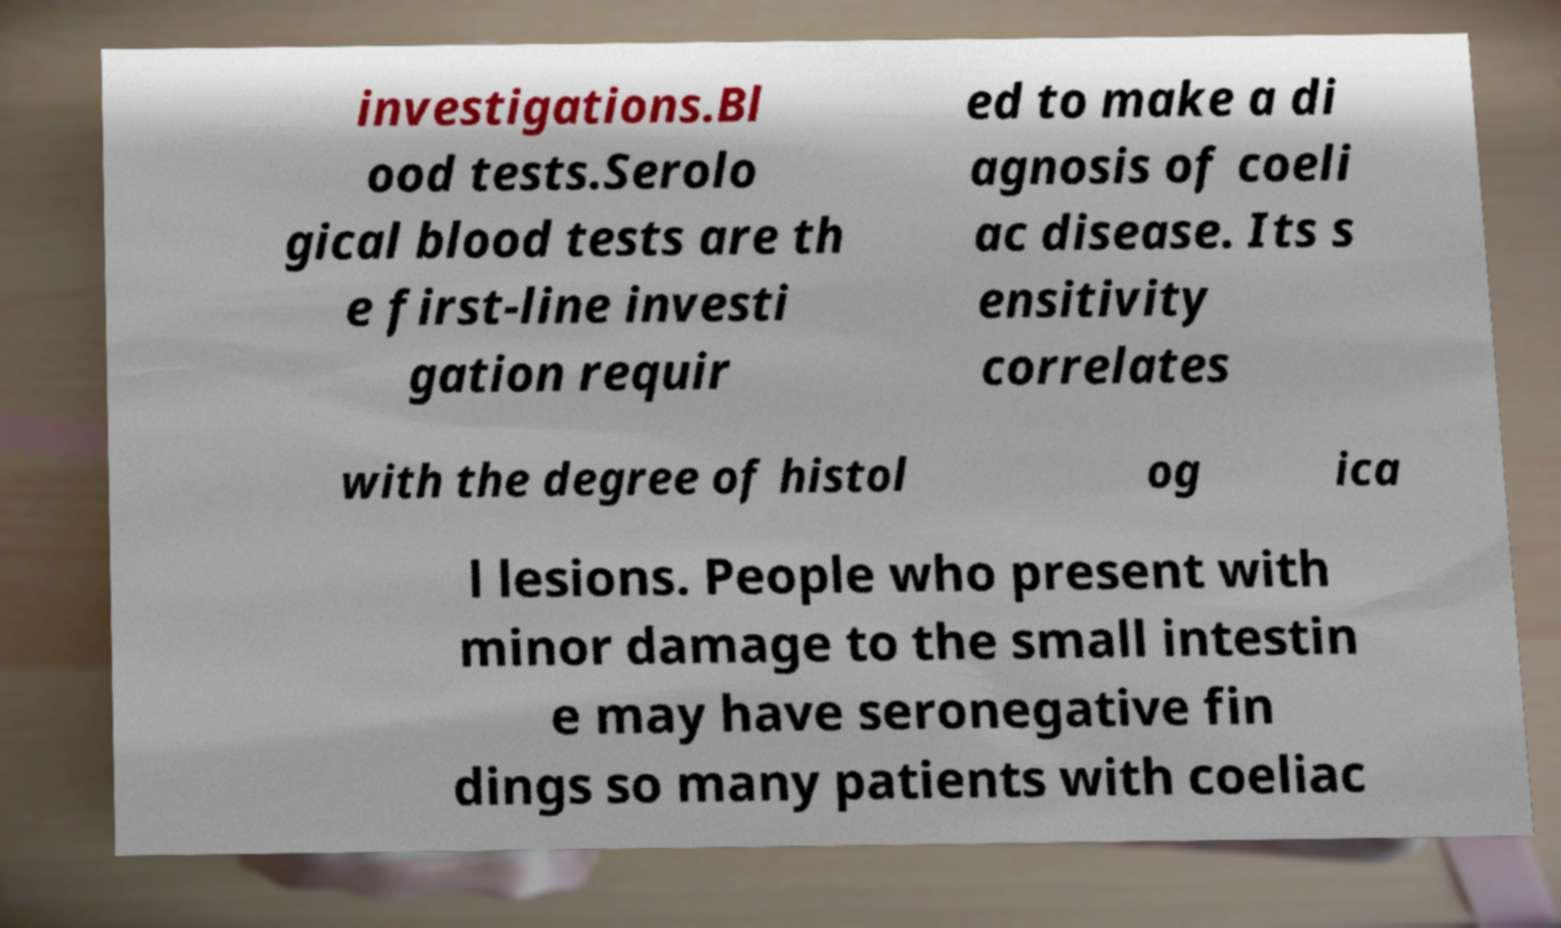I need the written content from this picture converted into text. Can you do that? investigations.Bl ood tests.Serolo gical blood tests are th e first-line investi gation requir ed to make a di agnosis of coeli ac disease. Its s ensitivity correlates with the degree of histol og ica l lesions. People who present with minor damage to the small intestin e may have seronegative fin dings so many patients with coeliac 